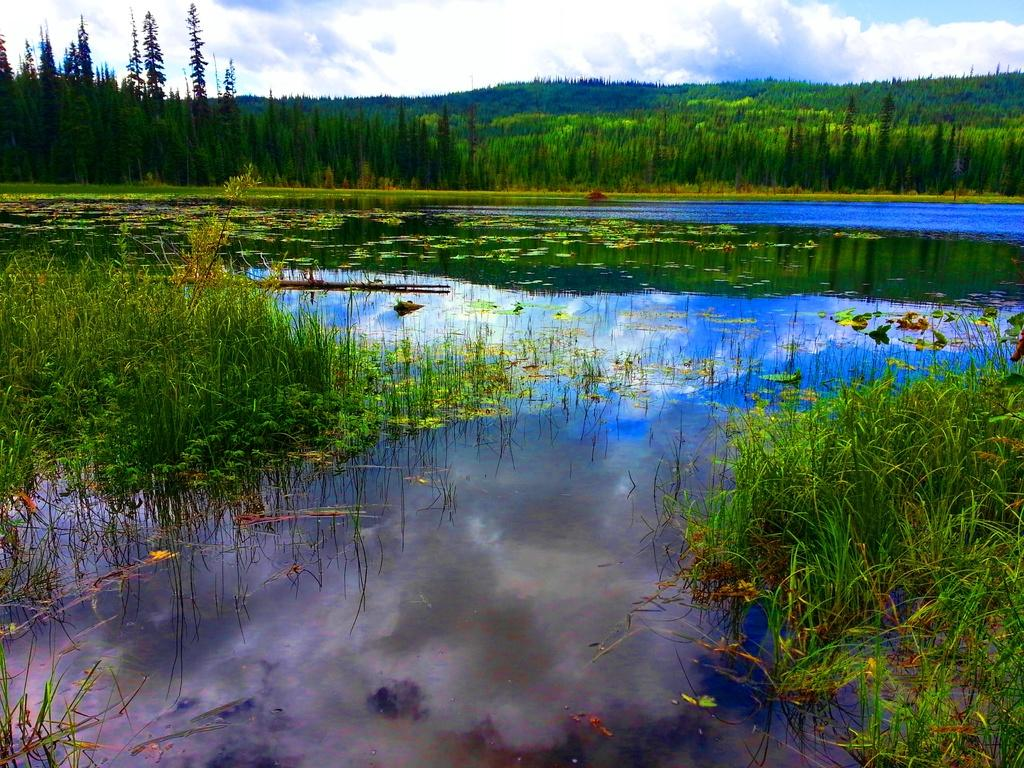What is in the foreground of the image? There is water and grass in the foreground of the image. What type of vegetation can be seen in the foreground? Grass is visible in the foreground of the image. What is visible in the background of the image? There are trees and the sky in the background of the image. What part of the natural environment is visible in the background? The sky and trees are visible in the background of the image. How much money is being exchanged between the chickens in the image? There are no chickens present in the image, and therefore no money exchange can be observed. What type of nation is depicted in the image? The image does not depict any nation; it features water, grass, trees, and the sky. 